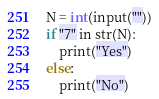Convert code to text. <code><loc_0><loc_0><loc_500><loc_500><_C_>N = int(input(""))
if "7" in str(N):
    print("Yes")
else:
    print("No")</code> 